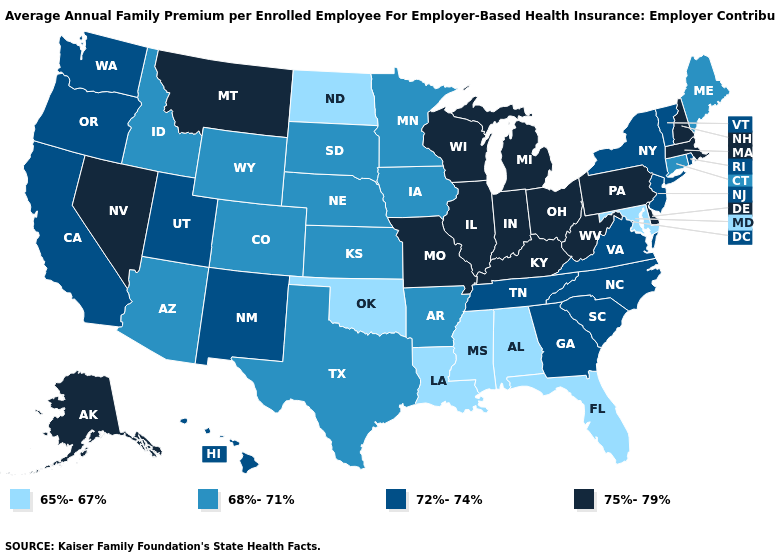Among the states that border Illinois , does Iowa have the lowest value?
Quick response, please. Yes. Name the states that have a value in the range 65%-67%?
Give a very brief answer. Alabama, Florida, Louisiana, Maryland, Mississippi, North Dakota, Oklahoma. What is the value of Idaho?
Short answer required. 68%-71%. What is the value of Connecticut?
Write a very short answer. 68%-71%. Does Alabama have the lowest value in the USA?
Keep it brief. Yes. What is the lowest value in states that border Arkansas?
Keep it brief. 65%-67%. Which states have the lowest value in the South?
Keep it brief. Alabama, Florida, Louisiana, Maryland, Mississippi, Oklahoma. What is the highest value in the USA?
Be succinct. 75%-79%. Among the states that border New Hampshire , does Vermont have the highest value?
Short answer required. No. What is the highest value in the South ?
Short answer required. 75%-79%. What is the value of West Virginia?
Quick response, please. 75%-79%. Does the map have missing data?
Answer briefly. No. Does Florida have the lowest value in the USA?
Keep it brief. Yes. Which states have the lowest value in the USA?
Answer briefly. Alabama, Florida, Louisiana, Maryland, Mississippi, North Dakota, Oklahoma. 